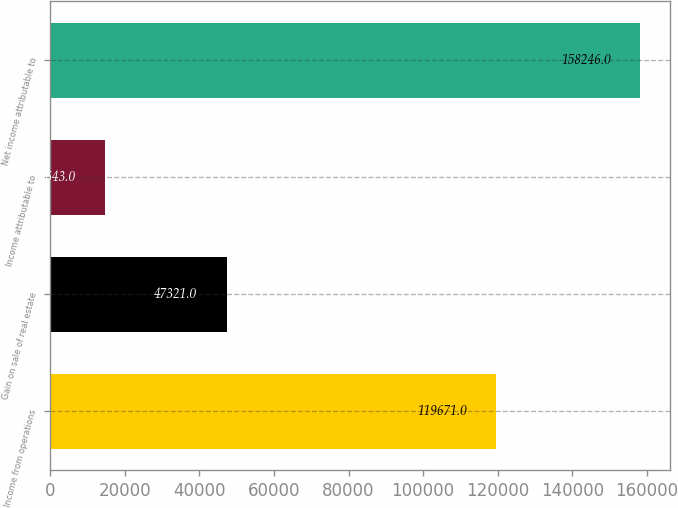Convert chart. <chart><loc_0><loc_0><loc_500><loc_500><bar_chart><fcel>Income from operations<fcel>Gain on sale of real estate<fcel>Income attributable to<fcel>Net income attributable to<nl><fcel>119671<fcel>47321<fcel>14643<fcel>158246<nl></chart> 